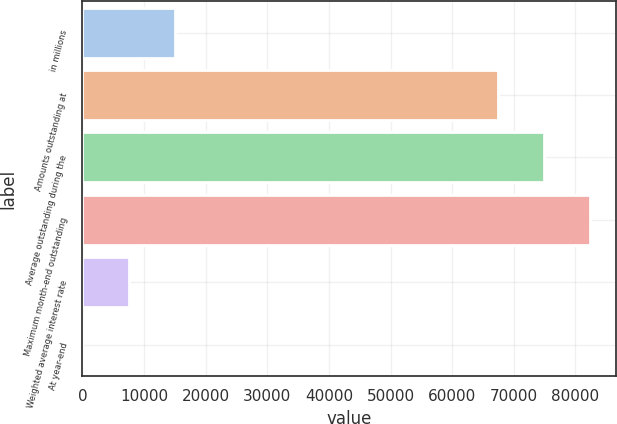Convert chart. <chart><loc_0><loc_0><loc_500><loc_500><bar_chart><fcel>in millions<fcel>Amounts outstanding at<fcel>Average outstanding during the<fcel>Maximum month-end outstanding<fcel>Weighted average interest rate<fcel>At year-end<nl><fcel>15056.6<fcel>67349<fcel>74876.9<fcel>82404.8<fcel>7528.71<fcel>0.79<nl></chart> 